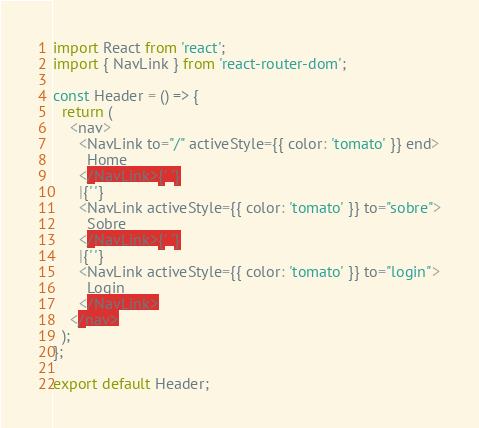<code> <loc_0><loc_0><loc_500><loc_500><_JavaScript_>import React from 'react';
import { NavLink } from 'react-router-dom';

const Header = () => {
  return (
    <nav>
      <NavLink to="/" activeStyle={{ color: 'tomato' }} end>
        Home
      </NavLink>{' '}
      |{' '}
      <NavLink activeStyle={{ color: 'tomato' }} to="sobre">
        Sobre
      </NavLink>{' '}
      |{' '}
      <NavLink activeStyle={{ color: 'tomato' }} to="login">
        Login
      </NavLink>
    </nav>
  );
};

export default Header;
</code> 